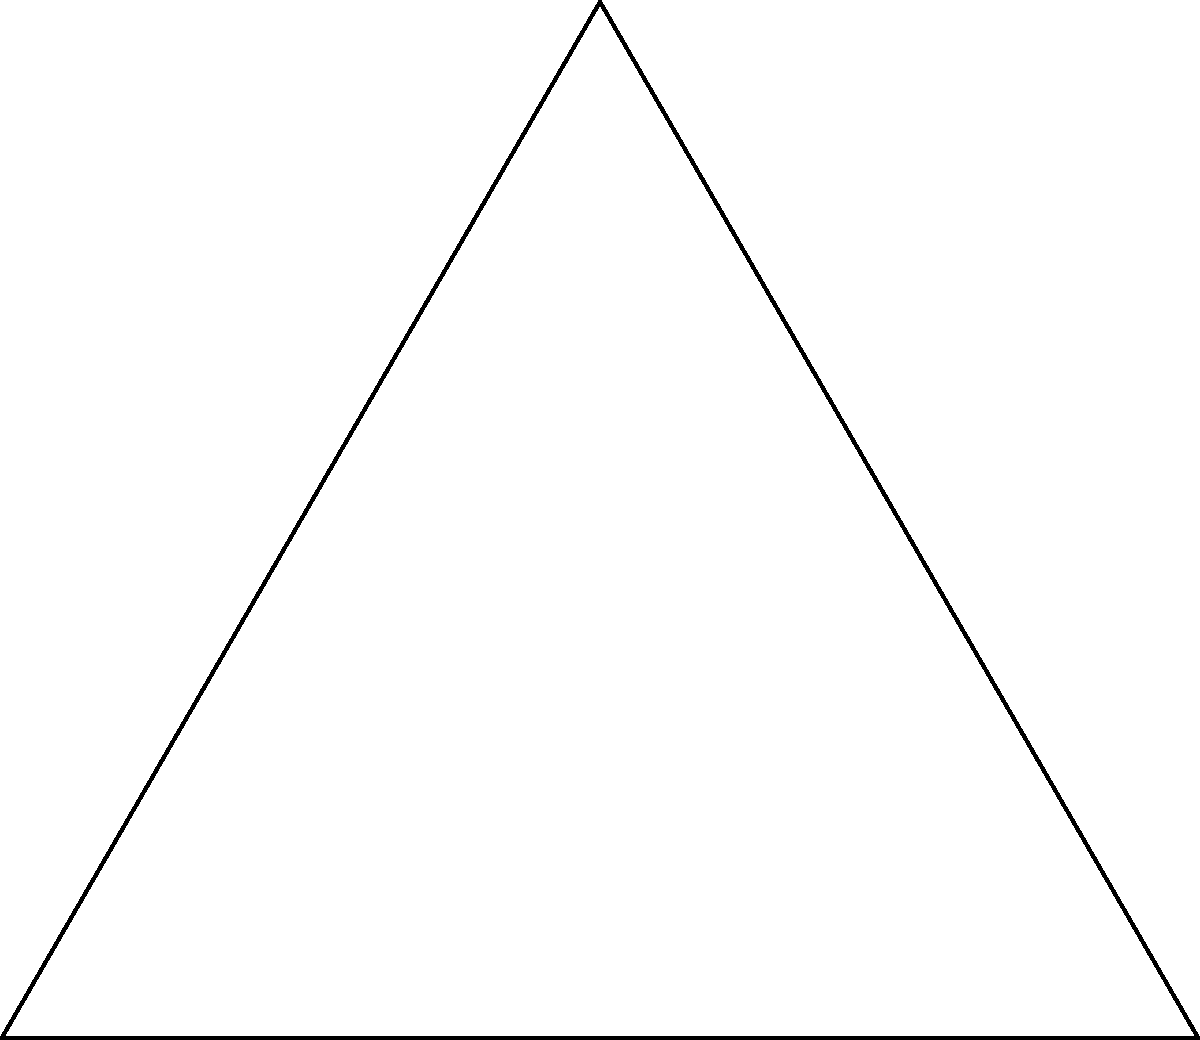In the figure, an equilateral triangle ABC has side length $a$. A circle is inscribed within the triangle, touching all three sides. Calculate the area of the inscribed circle in terms of $a$. Let's approach this step-by-step:

1) In an equilateral triangle, the radius of the inscribed circle ($r$) is related to the side length ($a$) by the formula:

   $$r = \frac{a}{2\sqrt{3}}$$

2) The area of a circle is given by the formula:

   $$A = \pi r^2$$

3) Substituting the expression for $r$ into the area formula:

   $$A = \pi (\frac{a}{2\sqrt{3}})^2$$

4) Simplify:
   
   $$A = \pi \frac{a^2}{12}$$

5) This can be further simplified to:

   $$A = \frac{\pi a^2}{12}$$

This formula gives the area of the inscribed circle in terms of the side length $a$ of the equilateral triangle.
Answer: $\frac{\pi a^2}{12}$ 